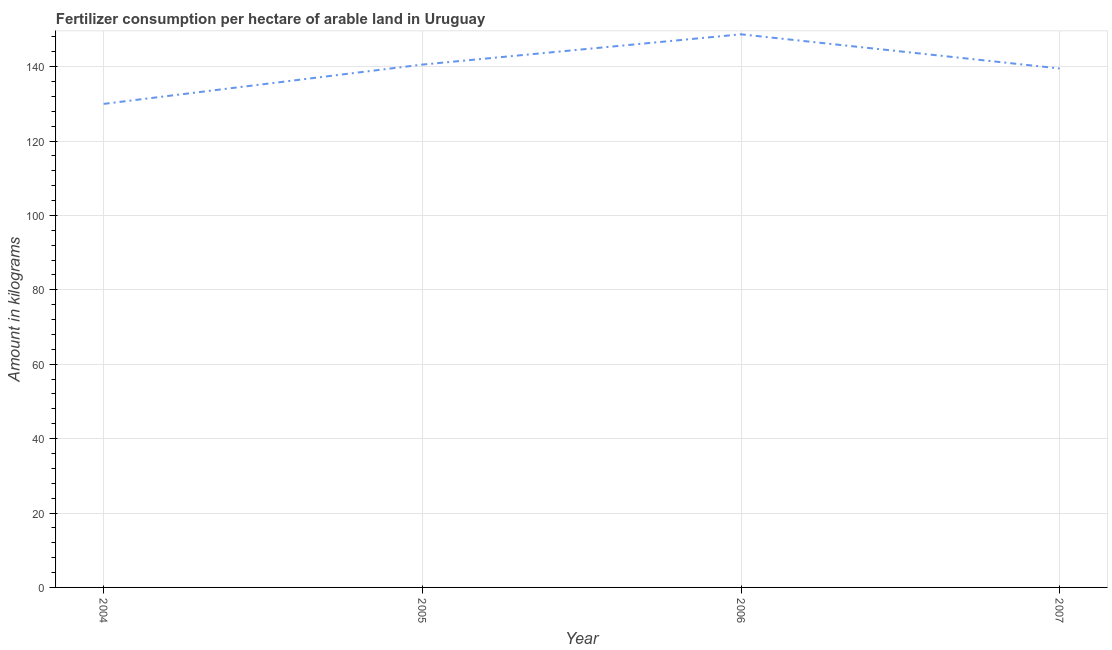What is the amount of fertilizer consumption in 2006?
Keep it short and to the point. 148.7. Across all years, what is the maximum amount of fertilizer consumption?
Offer a terse response. 148.7. Across all years, what is the minimum amount of fertilizer consumption?
Your answer should be very brief. 129.99. What is the sum of the amount of fertilizer consumption?
Provide a succinct answer. 558.75. What is the difference between the amount of fertilizer consumption in 2006 and 2007?
Your answer should be compact. 9.19. What is the average amount of fertilizer consumption per year?
Provide a succinct answer. 139.69. What is the median amount of fertilizer consumption?
Provide a short and direct response. 140.03. In how many years, is the amount of fertilizer consumption greater than 44 kg?
Your response must be concise. 4. What is the ratio of the amount of fertilizer consumption in 2006 to that in 2007?
Your answer should be compact. 1.07. Is the difference between the amount of fertilizer consumption in 2004 and 2005 greater than the difference between any two years?
Your answer should be very brief. No. What is the difference between the highest and the second highest amount of fertilizer consumption?
Provide a succinct answer. 8.14. What is the difference between the highest and the lowest amount of fertilizer consumption?
Ensure brevity in your answer.  18.71. Does the amount of fertilizer consumption monotonically increase over the years?
Provide a short and direct response. No. How many lines are there?
Offer a very short reply. 1. How many years are there in the graph?
Your answer should be compact. 4. What is the difference between two consecutive major ticks on the Y-axis?
Your answer should be very brief. 20. Are the values on the major ticks of Y-axis written in scientific E-notation?
Provide a short and direct response. No. Does the graph contain any zero values?
Provide a short and direct response. No. Does the graph contain grids?
Give a very brief answer. Yes. What is the title of the graph?
Ensure brevity in your answer.  Fertilizer consumption per hectare of arable land in Uruguay . What is the label or title of the X-axis?
Provide a succinct answer. Year. What is the label or title of the Y-axis?
Your answer should be very brief. Amount in kilograms. What is the Amount in kilograms of 2004?
Offer a very short reply. 129.99. What is the Amount in kilograms in 2005?
Ensure brevity in your answer.  140.56. What is the Amount in kilograms of 2006?
Your response must be concise. 148.7. What is the Amount in kilograms in 2007?
Keep it short and to the point. 139.51. What is the difference between the Amount in kilograms in 2004 and 2005?
Offer a terse response. -10.57. What is the difference between the Amount in kilograms in 2004 and 2006?
Keep it short and to the point. -18.71. What is the difference between the Amount in kilograms in 2004 and 2007?
Your answer should be very brief. -9.52. What is the difference between the Amount in kilograms in 2005 and 2006?
Keep it short and to the point. -8.14. What is the difference between the Amount in kilograms in 2005 and 2007?
Your response must be concise. 1.04. What is the difference between the Amount in kilograms in 2006 and 2007?
Provide a short and direct response. 9.19. What is the ratio of the Amount in kilograms in 2004 to that in 2005?
Provide a succinct answer. 0.93. What is the ratio of the Amount in kilograms in 2004 to that in 2006?
Offer a very short reply. 0.87. What is the ratio of the Amount in kilograms in 2004 to that in 2007?
Ensure brevity in your answer.  0.93. What is the ratio of the Amount in kilograms in 2005 to that in 2006?
Make the answer very short. 0.94. What is the ratio of the Amount in kilograms in 2006 to that in 2007?
Give a very brief answer. 1.07. 